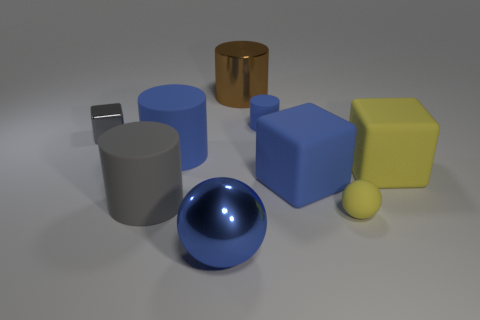How many other things are the same material as the small yellow sphere?
Your response must be concise. 5. Is the shape of the metal object on the left side of the large metal ball the same as  the big yellow matte thing?
Your answer should be compact. Yes. What number of tiny things are brown cylinders or gray metallic cylinders?
Offer a terse response. 0. Is the number of gray cylinders that are right of the matte sphere the same as the number of cubes on the right side of the big blue metal sphere?
Offer a very short reply. No. How many other things are the same color as the matte ball?
Provide a short and direct response. 1. Does the tiny cube have the same color as the cylinder that is on the left side of the big blue cylinder?
Give a very brief answer. Yes. What number of yellow things are small metallic objects or rubber objects?
Provide a succinct answer. 2. Is the number of small cubes that are left of the tiny gray object the same as the number of red cubes?
Ensure brevity in your answer.  Yes. There is another shiny object that is the same shape as the small yellow thing; what is its color?
Ensure brevity in your answer.  Blue. How many rubber objects have the same shape as the big brown metal object?
Provide a succinct answer. 3. 